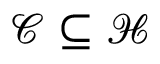Convert formula to latex. <formula><loc_0><loc_0><loc_500><loc_500>{ \mathcal { C } } \subseteq { \mathcal { H } }</formula> 